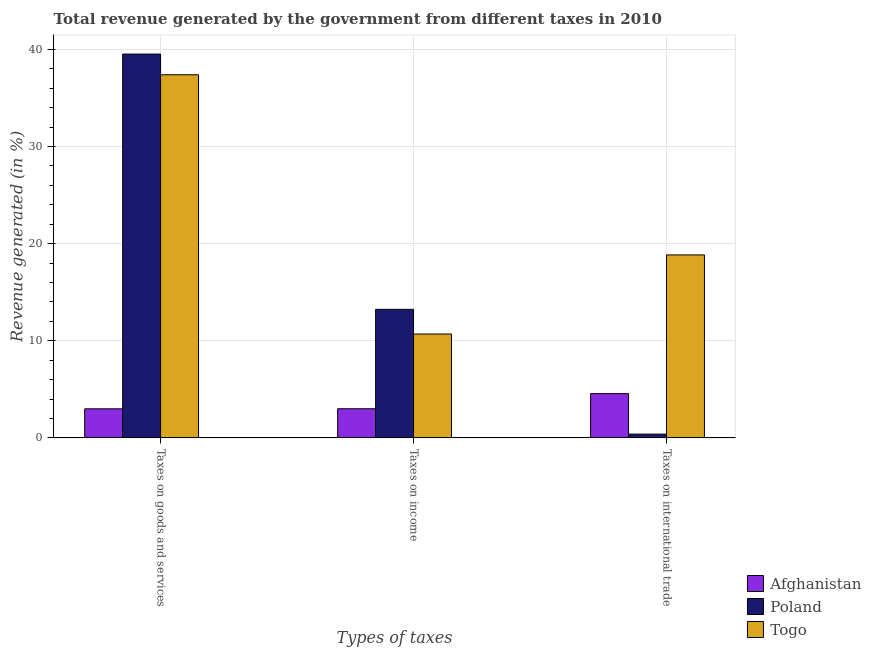How many different coloured bars are there?
Provide a succinct answer. 3. Are the number of bars per tick equal to the number of legend labels?
Make the answer very short. Yes. Are the number of bars on each tick of the X-axis equal?
Your answer should be very brief. Yes. How many bars are there on the 2nd tick from the right?
Make the answer very short. 3. What is the label of the 1st group of bars from the left?
Make the answer very short. Taxes on goods and services. What is the percentage of revenue generated by taxes on income in Poland?
Provide a succinct answer. 13.23. Across all countries, what is the maximum percentage of revenue generated by taxes on goods and services?
Offer a terse response. 39.52. Across all countries, what is the minimum percentage of revenue generated by tax on international trade?
Your response must be concise. 0.39. In which country was the percentage of revenue generated by tax on international trade maximum?
Your answer should be compact. Togo. In which country was the percentage of revenue generated by taxes on goods and services minimum?
Ensure brevity in your answer.  Afghanistan. What is the total percentage of revenue generated by taxes on goods and services in the graph?
Make the answer very short. 79.91. What is the difference between the percentage of revenue generated by taxes on goods and services in Togo and that in Afghanistan?
Your answer should be compact. 34.4. What is the difference between the percentage of revenue generated by tax on international trade in Togo and the percentage of revenue generated by taxes on goods and services in Afghanistan?
Offer a very short reply. 15.85. What is the average percentage of revenue generated by taxes on income per country?
Keep it short and to the point. 8.98. What is the difference between the percentage of revenue generated by taxes on income and percentage of revenue generated by tax on international trade in Togo?
Make the answer very short. -8.15. In how many countries, is the percentage of revenue generated by taxes on goods and services greater than 30 %?
Provide a short and direct response. 2. What is the ratio of the percentage of revenue generated by taxes on goods and services in Poland to that in Togo?
Provide a short and direct response. 1.06. What is the difference between the highest and the second highest percentage of revenue generated by tax on international trade?
Your answer should be very brief. 14.28. What is the difference between the highest and the lowest percentage of revenue generated by taxes on goods and services?
Your answer should be very brief. 36.53. In how many countries, is the percentage of revenue generated by tax on international trade greater than the average percentage of revenue generated by tax on international trade taken over all countries?
Keep it short and to the point. 1. Is the sum of the percentage of revenue generated by tax on international trade in Poland and Togo greater than the maximum percentage of revenue generated by taxes on income across all countries?
Provide a short and direct response. Yes. What does the 3rd bar from the left in Taxes on international trade represents?
Provide a succinct answer. Togo. What does the 1st bar from the right in Taxes on goods and services represents?
Give a very brief answer. Togo. Is it the case that in every country, the sum of the percentage of revenue generated by taxes on goods and services and percentage of revenue generated by taxes on income is greater than the percentage of revenue generated by tax on international trade?
Give a very brief answer. Yes. How many bars are there?
Offer a terse response. 9. What is the difference between two consecutive major ticks on the Y-axis?
Give a very brief answer. 10. Where does the legend appear in the graph?
Provide a succinct answer. Bottom right. How many legend labels are there?
Your response must be concise. 3. What is the title of the graph?
Keep it short and to the point. Total revenue generated by the government from different taxes in 2010. Does "Northern Mariana Islands" appear as one of the legend labels in the graph?
Your response must be concise. No. What is the label or title of the X-axis?
Ensure brevity in your answer.  Types of taxes. What is the label or title of the Y-axis?
Offer a very short reply. Revenue generated (in %). What is the Revenue generated (in %) in Afghanistan in Taxes on goods and services?
Provide a succinct answer. 2.99. What is the Revenue generated (in %) in Poland in Taxes on goods and services?
Give a very brief answer. 39.52. What is the Revenue generated (in %) of Togo in Taxes on goods and services?
Ensure brevity in your answer.  37.39. What is the Revenue generated (in %) of Afghanistan in Taxes on income?
Your answer should be very brief. 3. What is the Revenue generated (in %) in Poland in Taxes on income?
Your response must be concise. 13.23. What is the Revenue generated (in %) of Togo in Taxes on income?
Provide a succinct answer. 10.69. What is the Revenue generated (in %) in Afghanistan in Taxes on international trade?
Provide a succinct answer. 4.55. What is the Revenue generated (in %) in Poland in Taxes on international trade?
Your response must be concise. 0.39. What is the Revenue generated (in %) in Togo in Taxes on international trade?
Ensure brevity in your answer.  18.84. Across all Types of taxes, what is the maximum Revenue generated (in %) of Afghanistan?
Your answer should be very brief. 4.55. Across all Types of taxes, what is the maximum Revenue generated (in %) of Poland?
Provide a short and direct response. 39.52. Across all Types of taxes, what is the maximum Revenue generated (in %) of Togo?
Give a very brief answer. 37.39. Across all Types of taxes, what is the minimum Revenue generated (in %) in Afghanistan?
Your response must be concise. 2.99. Across all Types of taxes, what is the minimum Revenue generated (in %) of Poland?
Offer a terse response. 0.39. Across all Types of taxes, what is the minimum Revenue generated (in %) of Togo?
Your answer should be compact. 10.69. What is the total Revenue generated (in %) in Afghanistan in the graph?
Make the answer very short. 10.55. What is the total Revenue generated (in %) of Poland in the graph?
Offer a terse response. 53.14. What is the total Revenue generated (in %) of Togo in the graph?
Keep it short and to the point. 66.92. What is the difference between the Revenue generated (in %) in Afghanistan in Taxes on goods and services and that in Taxes on income?
Give a very brief answer. -0.01. What is the difference between the Revenue generated (in %) in Poland in Taxes on goods and services and that in Taxes on income?
Provide a succinct answer. 26.29. What is the difference between the Revenue generated (in %) in Togo in Taxes on goods and services and that in Taxes on income?
Keep it short and to the point. 26.7. What is the difference between the Revenue generated (in %) in Afghanistan in Taxes on goods and services and that in Taxes on international trade?
Your answer should be very brief. -1.56. What is the difference between the Revenue generated (in %) in Poland in Taxes on goods and services and that in Taxes on international trade?
Your answer should be compact. 39.14. What is the difference between the Revenue generated (in %) of Togo in Taxes on goods and services and that in Taxes on international trade?
Keep it short and to the point. 18.55. What is the difference between the Revenue generated (in %) in Afghanistan in Taxes on income and that in Taxes on international trade?
Provide a succinct answer. -1.56. What is the difference between the Revenue generated (in %) in Poland in Taxes on income and that in Taxes on international trade?
Provide a succinct answer. 12.85. What is the difference between the Revenue generated (in %) of Togo in Taxes on income and that in Taxes on international trade?
Offer a very short reply. -8.15. What is the difference between the Revenue generated (in %) of Afghanistan in Taxes on goods and services and the Revenue generated (in %) of Poland in Taxes on income?
Provide a succinct answer. -10.24. What is the difference between the Revenue generated (in %) in Afghanistan in Taxes on goods and services and the Revenue generated (in %) in Togo in Taxes on income?
Offer a very short reply. -7.7. What is the difference between the Revenue generated (in %) of Poland in Taxes on goods and services and the Revenue generated (in %) of Togo in Taxes on income?
Offer a terse response. 28.83. What is the difference between the Revenue generated (in %) in Afghanistan in Taxes on goods and services and the Revenue generated (in %) in Poland in Taxes on international trade?
Ensure brevity in your answer.  2.61. What is the difference between the Revenue generated (in %) in Afghanistan in Taxes on goods and services and the Revenue generated (in %) in Togo in Taxes on international trade?
Make the answer very short. -15.85. What is the difference between the Revenue generated (in %) in Poland in Taxes on goods and services and the Revenue generated (in %) in Togo in Taxes on international trade?
Keep it short and to the point. 20.68. What is the difference between the Revenue generated (in %) of Afghanistan in Taxes on income and the Revenue generated (in %) of Poland in Taxes on international trade?
Offer a terse response. 2.61. What is the difference between the Revenue generated (in %) of Afghanistan in Taxes on income and the Revenue generated (in %) of Togo in Taxes on international trade?
Give a very brief answer. -15.84. What is the difference between the Revenue generated (in %) of Poland in Taxes on income and the Revenue generated (in %) of Togo in Taxes on international trade?
Ensure brevity in your answer.  -5.61. What is the average Revenue generated (in %) of Afghanistan per Types of taxes?
Offer a very short reply. 3.52. What is the average Revenue generated (in %) in Poland per Types of taxes?
Offer a very short reply. 17.71. What is the average Revenue generated (in %) in Togo per Types of taxes?
Keep it short and to the point. 22.31. What is the difference between the Revenue generated (in %) of Afghanistan and Revenue generated (in %) of Poland in Taxes on goods and services?
Keep it short and to the point. -36.53. What is the difference between the Revenue generated (in %) in Afghanistan and Revenue generated (in %) in Togo in Taxes on goods and services?
Ensure brevity in your answer.  -34.4. What is the difference between the Revenue generated (in %) of Poland and Revenue generated (in %) of Togo in Taxes on goods and services?
Your answer should be very brief. 2.13. What is the difference between the Revenue generated (in %) of Afghanistan and Revenue generated (in %) of Poland in Taxes on income?
Make the answer very short. -10.23. What is the difference between the Revenue generated (in %) of Afghanistan and Revenue generated (in %) of Togo in Taxes on income?
Your answer should be very brief. -7.69. What is the difference between the Revenue generated (in %) in Poland and Revenue generated (in %) in Togo in Taxes on income?
Keep it short and to the point. 2.54. What is the difference between the Revenue generated (in %) of Afghanistan and Revenue generated (in %) of Poland in Taxes on international trade?
Make the answer very short. 4.17. What is the difference between the Revenue generated (in %) of Afghanistan and Revenue generated (in %) of Togo in Taxes on international trade?
Offer a very short reply. -14.28. What is the difference between the Revenue generated (in %) in Poland and Revenue generated (in %) in Togo in Taxes on international trade?
Your response must be concise. -18.45. What is the ratio of the Revenue generated (in %) of Poland in Taxes on goods and services to that in Taxes on income?
Make the answer very short. 2.99. What is the ratio of the Revenue generated (in %) of Togo in Taxes on goods and services to that in Taxes on income?
Give a very brief answer. 3.5. What is the ratio of the Revenue generated (in %) in Afghanistan in Taxes on goods and services to that in Taxes on international trade?
Provide a short and direct response. 0.66. What is the ratio of the Revenue generated (in %) in Poland in Taxes on goods and services to that in Taxes on international trade?
Keep it short and to the point. 102.31. What is the ratio of the Revenue generated (in %) in Togo in Taxes on goods and services to that in Taxes on international trade?
Provide a succinct answer. 1.98. What is the ratio of the Revenue generated (in %) of Afghanistan in Taxes on income to that in Taxes on international trade?
Give a very brief answer. 0.66. What is the ratio of the Revenue generated (in %) in Poland in Taxes on income to that in Taxes on international trade?
Provide a short and direct response. 34.26. What is the ratio of the Revenue generated (in %) in Togo in Taxes on income to that in Taxes on international trade?
Offer a terse response. 0.57. What is the difference between the highest and the second highest Revenue generated (in %) of Afghanistan?
Provide a succinct answer. 1.56. What is the difference between the highest and the second highest Revenue generated (in %) of Poland?
Ensure brevity in your answer.  26.29. What is the difference between the highest and the second highest Revenue generated (in %) in Togo?
Offer a very short reply. 18.55. What is the difference between the highest and the lowest Revenue generated (in %) of Afghanistan?
Your response must be concise. 1.56. What is the difference between the highest and the lowest Revenue generated (in %) in Poland?
Offer a very short reply. 39.14. What is the difference between the highest and the lowest Revenue generated (in %) in Togo?
Make the answer very short. 26.7. 